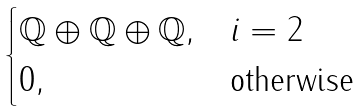<formula> <loc_0><loc_0><loc_500><loc_500>\begin{cases} \mathbb { Q } \oplus \mathbb { Q } \oplus \mathbb { Q } , & i = 2 \\ 0 , & \text {otherwise} \end{cases}</formula> 